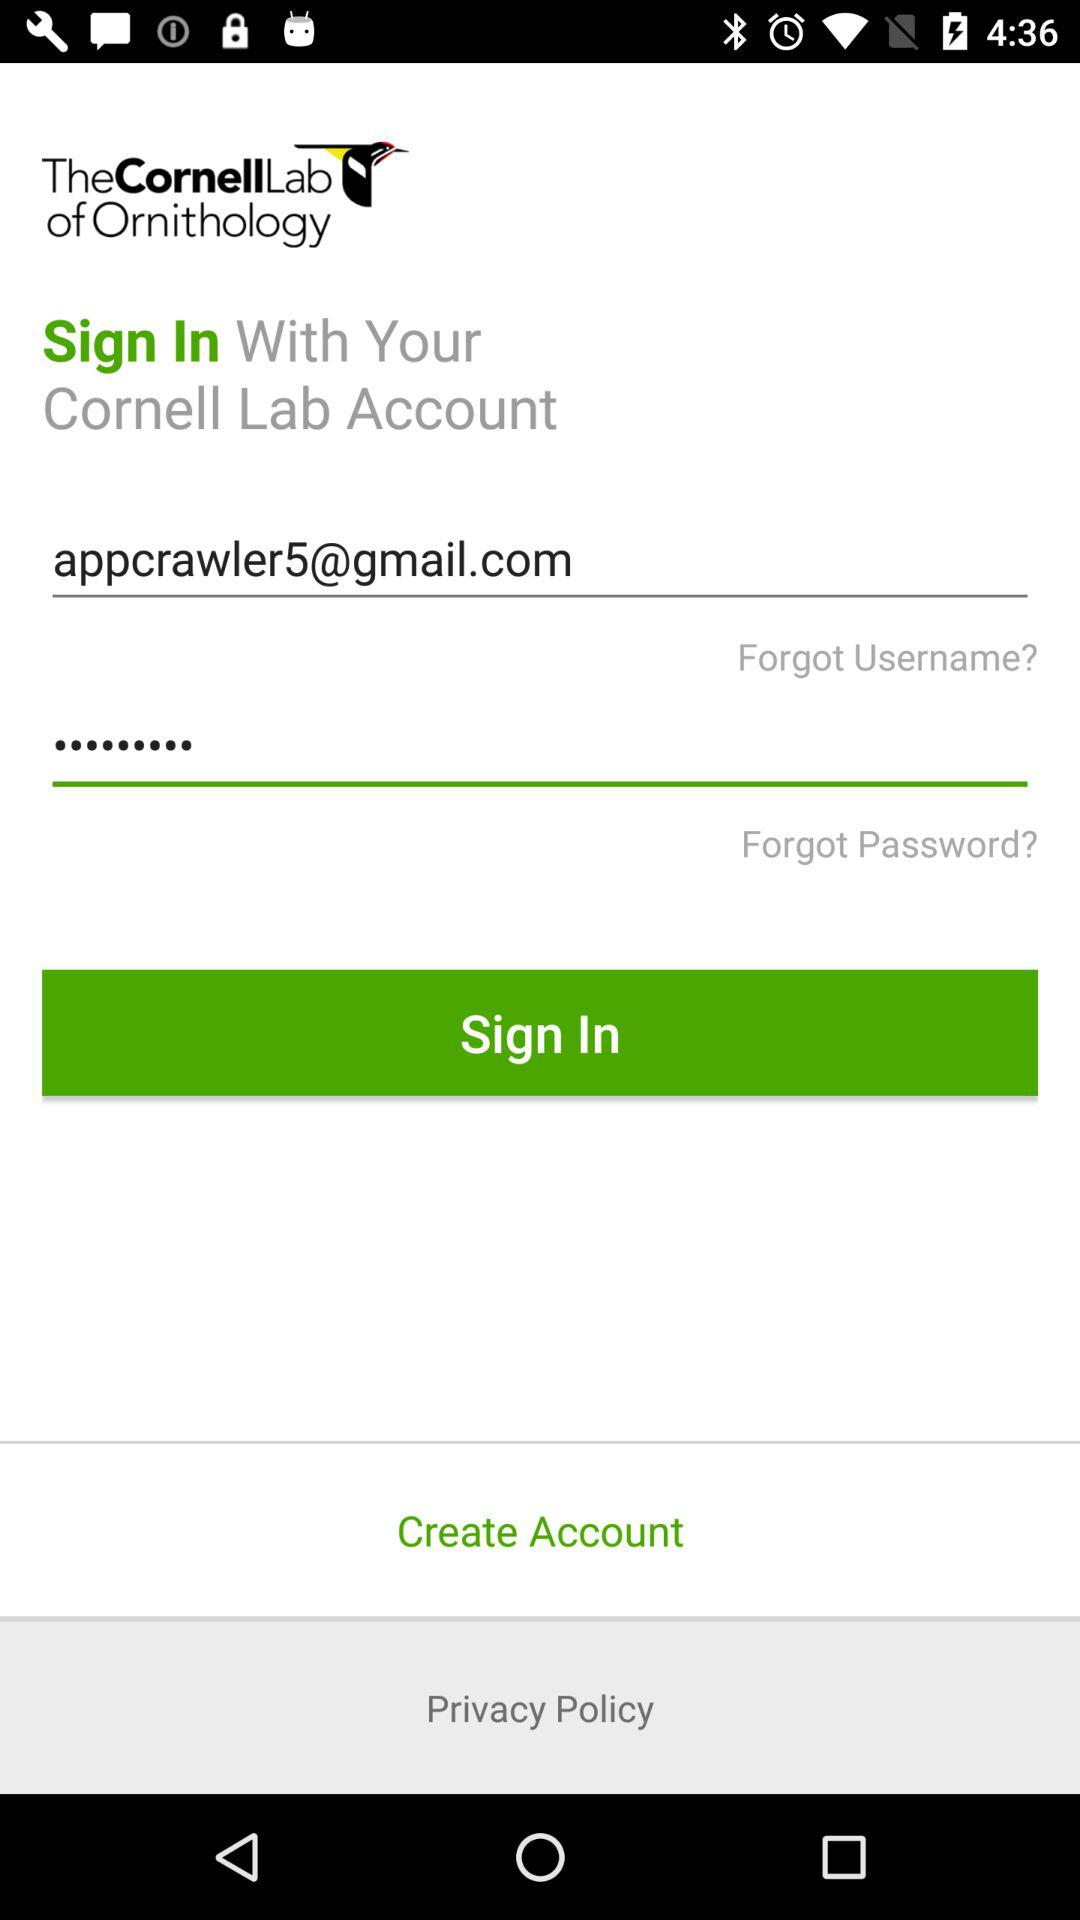What is the privacy policy?
When the provided information is insufficient, respond with <no answer>. <no answer> 